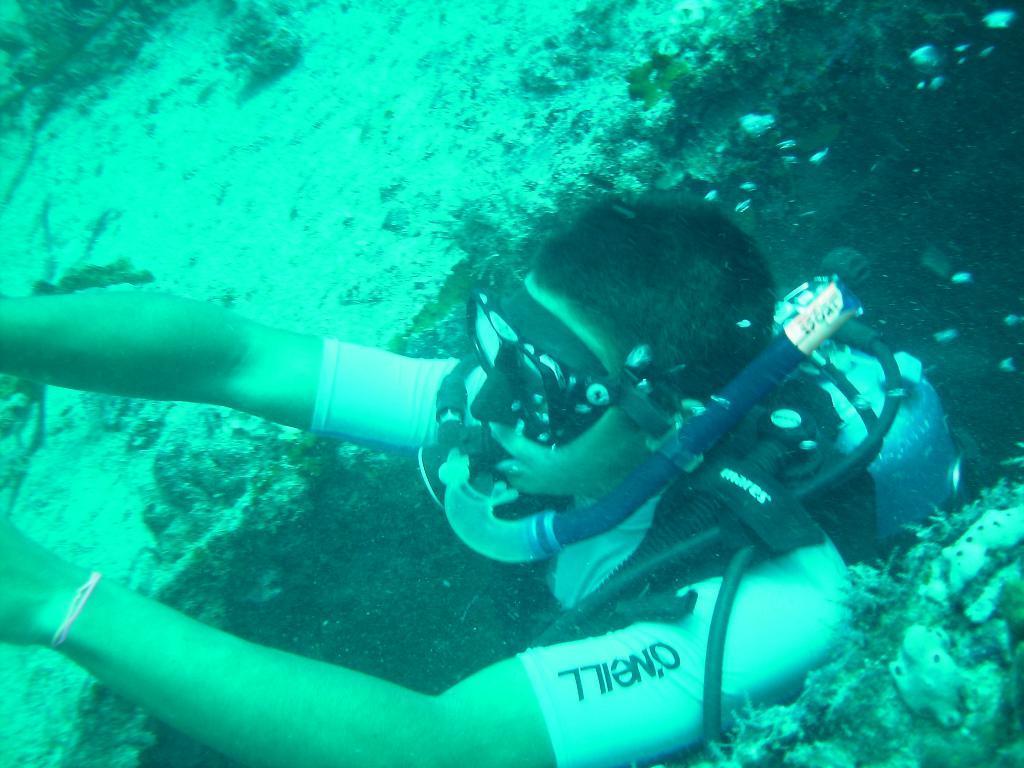Could you give a brief overview of what you see in this image? This image is taken under water. On the right side of the image there is a man. He has worn a diving mask and oxygen cylinder. There are some marine creatures. 